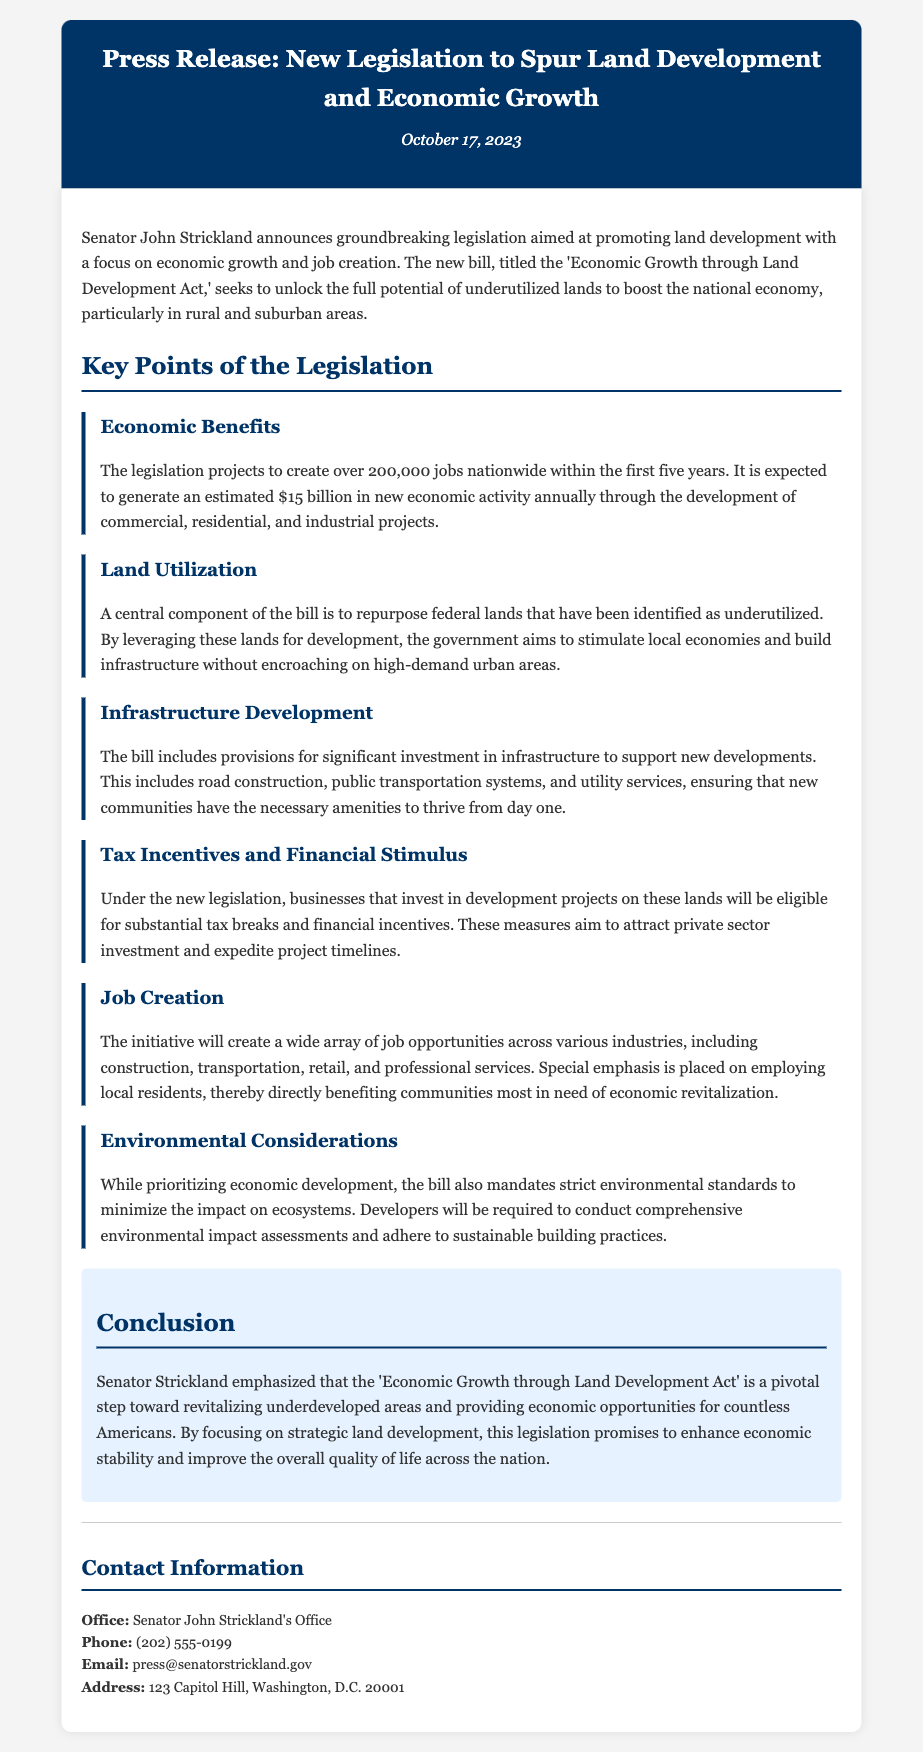What is the title of the new legislation? The title of the new legislation is mentioned as 'Economic Growth through Land Development Act'.
Answer: Economic Growth through Land Development Act Who announced the legislation? The announcement of the legislation was made by Senator John Strickland.
Answer: Senator John Strickland When was the press release published? The press release was published on October 17, 2023.
Answer: October 17, 2023 How many jobs is the legislation projected to create? The legislation is projected to create over 200,000 jobs nationwide.
Answer: 200,000 What type of projects does the bill focus on? The bill focuses on the development of commercial, residential, and industrial projects.
Answer: commercial, residential, and industrial projects What is the estimated annual economic activity generated by the legislation? The estimated annual economic activity generated by the legislation is $15 billion.
Answer: $15 billion Which provisions are included to support new developments? The bill includes provisions for significant investment in infrastructure.
Answer: significant investment in infrastructure What aspect does the bill emphasize regarding job opportunities? The bill emphasizes employing local residents for job opportunities.
Answer: employing local residents What is required from developers concerning the environment? Developers are required to conduct comprehensive environmental impact assessments.
Answer: comprehensive environmental impact assessments 